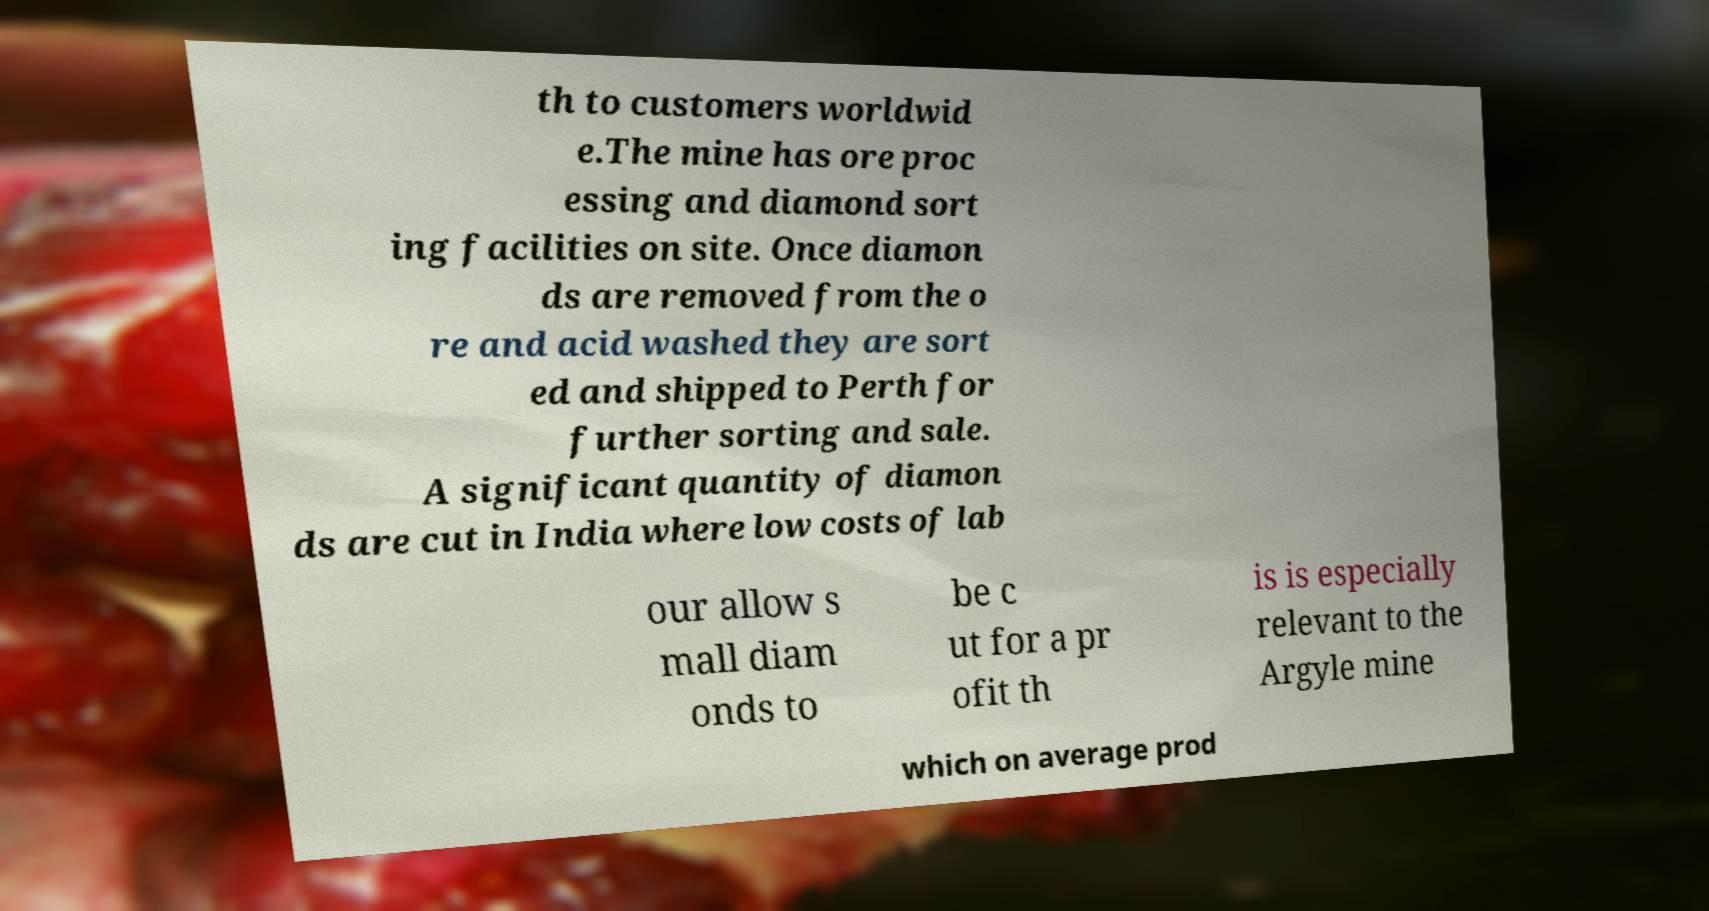Can you read and provide the text displayed in the image?This photo seems to have some interesting text. Can you extract and type it out for me? th to customers worldwid e.The mine has ore proc essing and diamond sort ing facilities on site. Once diamon ds are removed from the o re and acid washed they are sort ed and shipped to Perth for further sorting and sale. A significant quantity of diamon ds are cut in India where low costs of lab our allow s mall diam onds to be c ut for a pr ofit th is is especially relevant to the Argyle mine which on average prod 